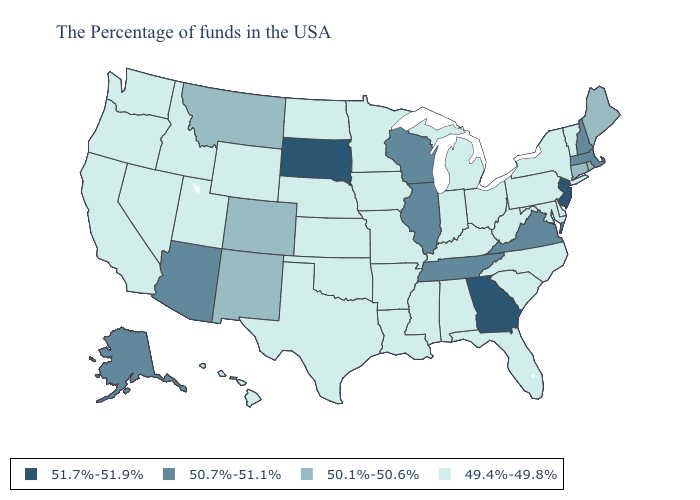Does the map have missing data?
Concise answer only. No. What is the lowest value in the MidWest?
Keep it brief. 49.4%-49.8%. What is the highest value in states that border Texas?
Concise answer only. 50.1%-50.6%. What is the lowest value in states that border California?
Give a very brief answer. 49.4%-49.8%. What is the value of Illinois?
Quick response, please. 50.7%-51.1%. Does South Dakota have the highest value in the USA?
Short answer required. Yes. What is the value of Maine?
Short answer required. 50.1%-50.6%. Among the states that border Illinois , which have the highest value?
Short answer required. Wisconsin. Does the map have missing data?
Keep it brief. No. What is the lowest value in the USA?
Concise answer only. 49.4%-49.8%. Name the states that have a value in the range 51.7%-51.9%?
Concise answer only. New Jersey, Georgia, South Dakota. Name the states that have a value in the range 51.7%-51.9%?
Answer briefly. New Jersey, Georgia, South Dakota. What is the value of Mississippi?
Give a very brief answer. 49.4%-49.8%. Name the states that have a value in the range 50.7%-51.1%?
Write a very short answer. Massachusetts, New Hampshire, Virginia, Tennessee, Wisconsin, Illinois, Arizona, Alaska. Name the states that have a value in the range 50.7%-51.1%?
Quick response, please. Massachusetts, New Hampshire, Virginia, Tennessee, Wisconsin, Illinois, Arizona, Alaska. 